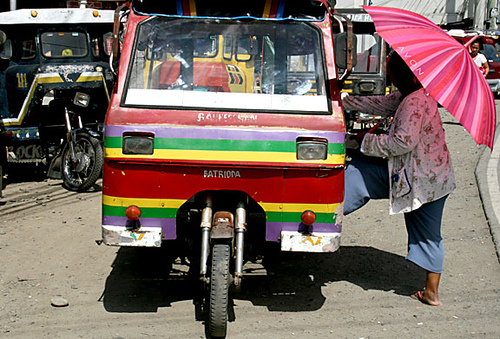Please transcribe the text in this image. FATRIONA ROCK AVON 